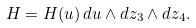Convert formula to latex. <formula><loc_0><loc_0><loc_500><loc_500>H = H ( u ) \, d u \wedge d z _ { 3 } \wedge d z _ { 4 } .</formula> 